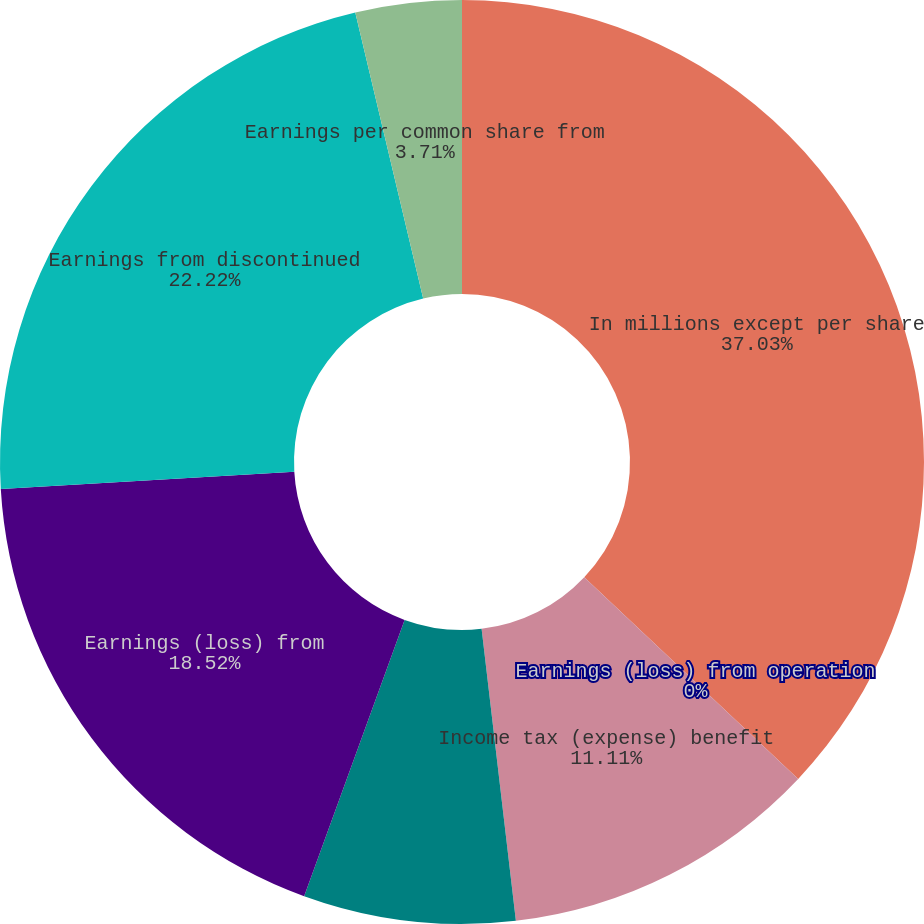Convert chart. <chart><loc_0><loc_0><loc_500><loc_500><pie_chart><fcel>In millions except per share<fcel>Earnings (loss) from operation<fcel>Income tax (expense) benefit<fcel>Minority interest (expense)<fcel>Earnings (loss) from<fcel>Earnings from discontinued<fcel>Earnings per common share from<nl><fcel>37.03%<fcel>0.0%<fcel>11.11%<fcel>7.41%<fcel>18.52%<fcel>22.22%<fcel>3.71%<nl></chart> 